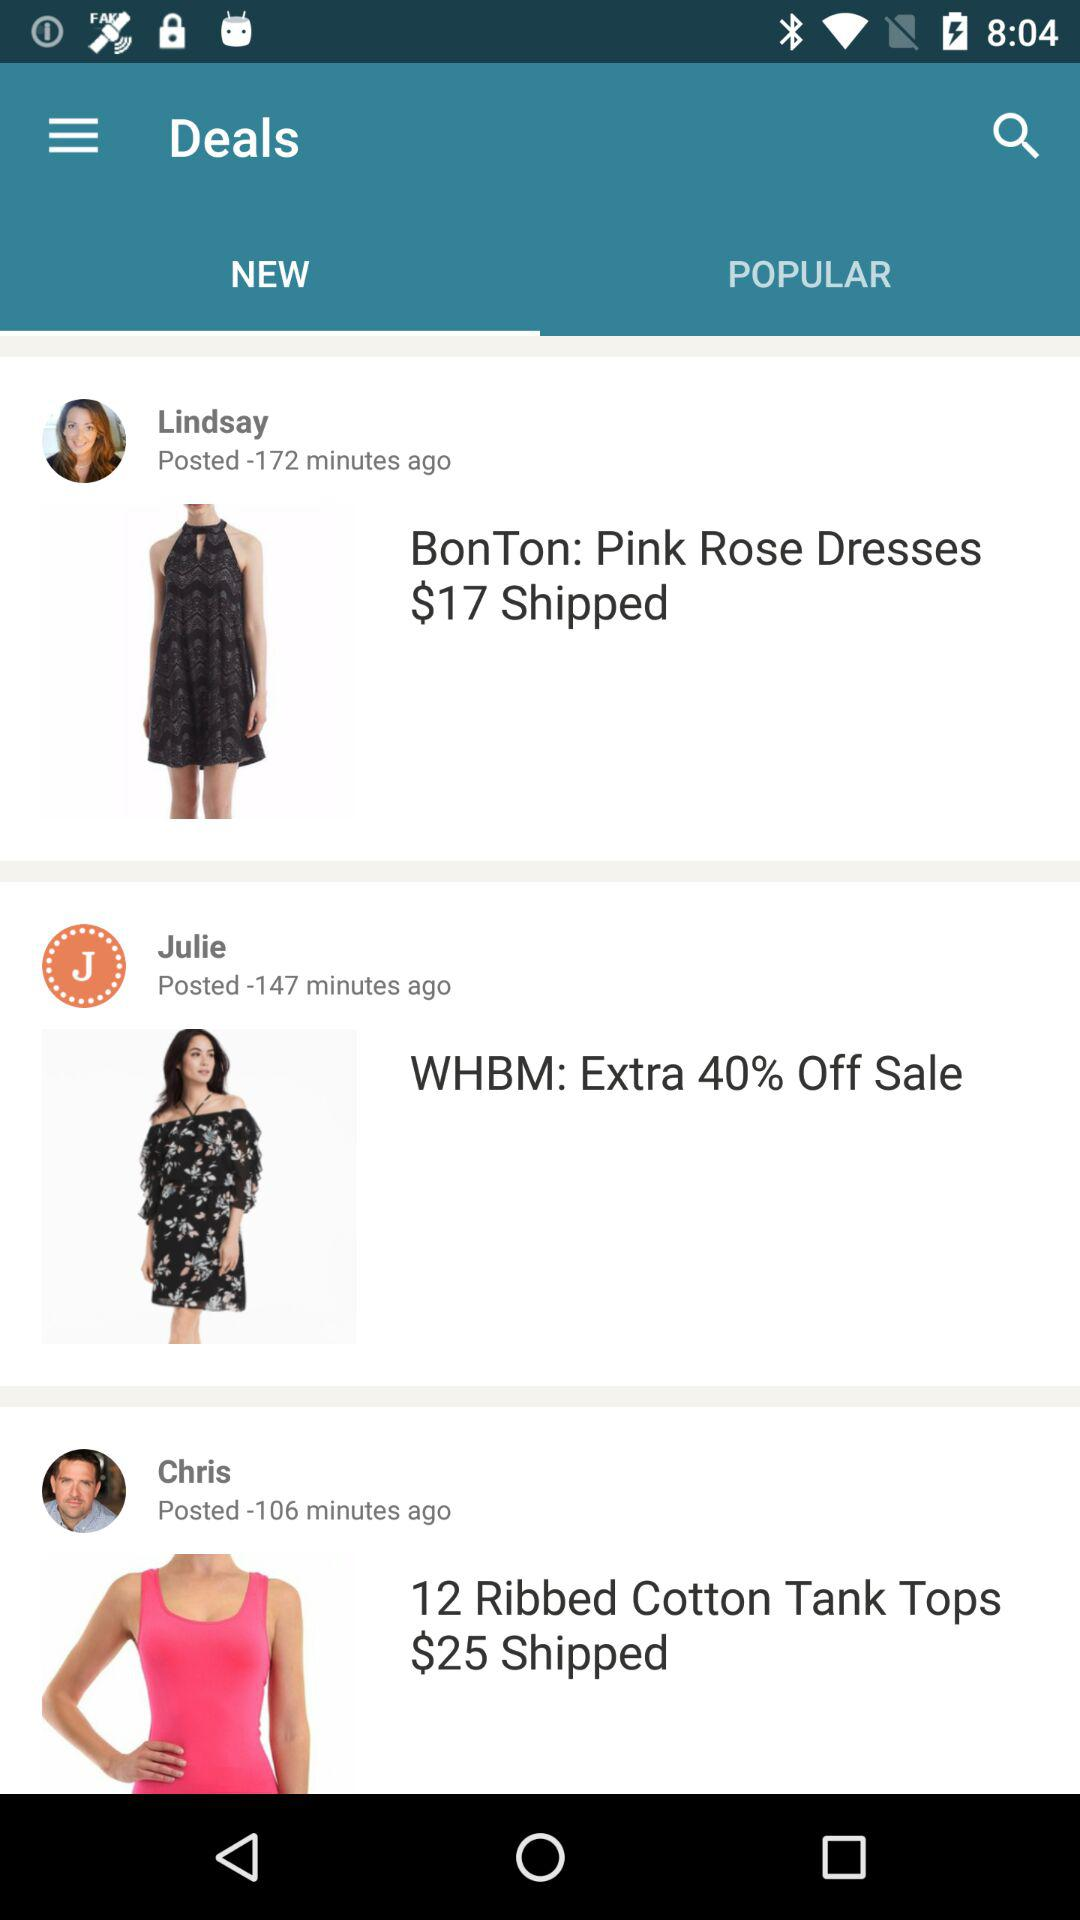How many minutes ago was the second most recent deal posted?
Answer the question using a single word or phrase. -147 